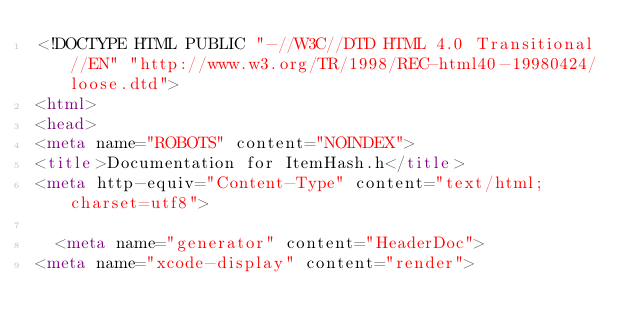Convert code to text. <code><loc_0><loc_0><loc_500><loc_500><_HTML_><!DOCTYPE HTML PUBLIC "-//W3C//DTD HTML 4.0 Transitional//EN" "http://www.w3.org/TR/1998/REC-html40-19980424/loose.dtd">
<html>
<head>
<meta name="ROBOTS" content="NOINDEX">
<title>Documentation for ItemHash.h</title>
<meta http-equiv="Content-Type" content="text/html; charset=utf8">

	<meta name="generator" content="HeaderDoc">
<meta name="xcode-display" content="render"></code> 